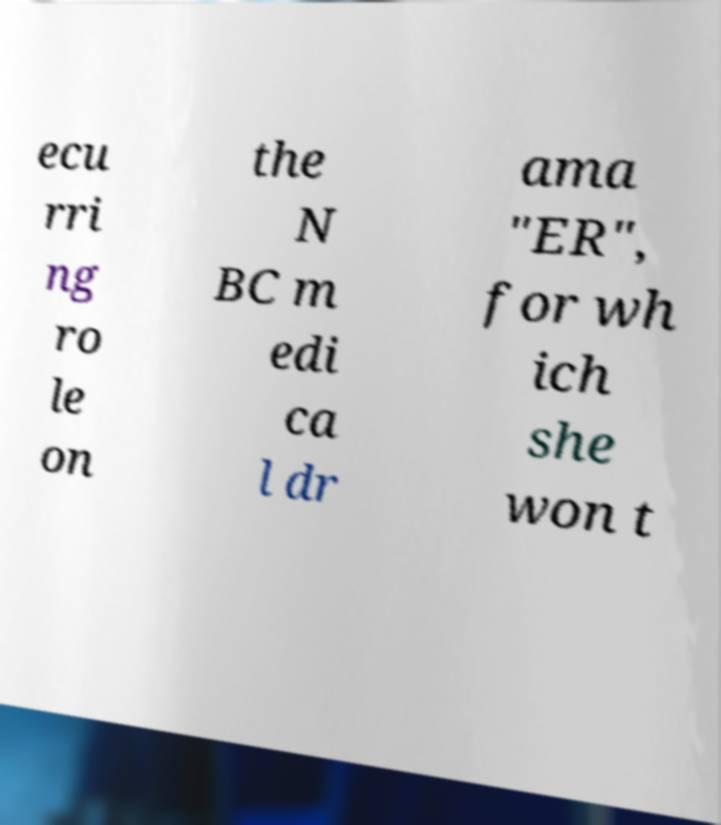Could you extract and type out the text from this image? ecu rri ng ro le on the N BC m edi ca l dr ama "ER", for wh ich she won t 